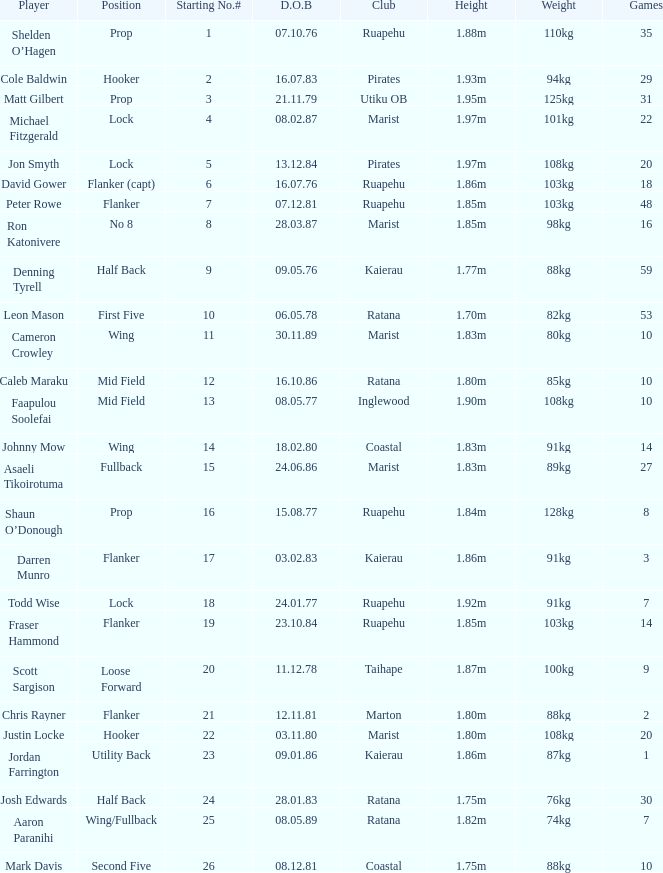Can you tell me the player's date of birth in the inglewood club? 80577.0. 